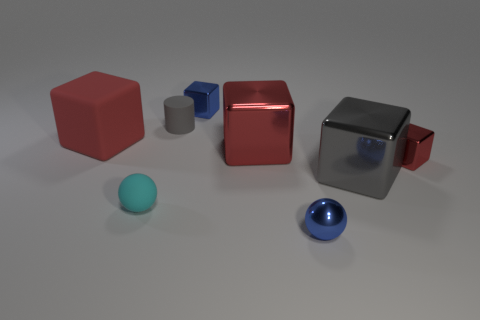Subtract all red cylinders. How many red cubes are left? 3 Subtract 2 cubes. How many cubes are left? 3 Subtract all blue cubes. How many cubes are left? 4 Subtract all large red matte blocks. How many blocks are left? 4 Add 1 small rubber things. How many objects exist? 9 Subtract all gray cubes. Subtract all green cylinders. How many cubes are left? 4 Subtract all spheres. How many objects are left? 6 Subtract 0 red balls. How many objects are left? 8 Subtract all yellow matte objects. Subtract all cylinders. How many objects are left? 7 Add 8 gray metal things. How many gray metal things are left? 9 